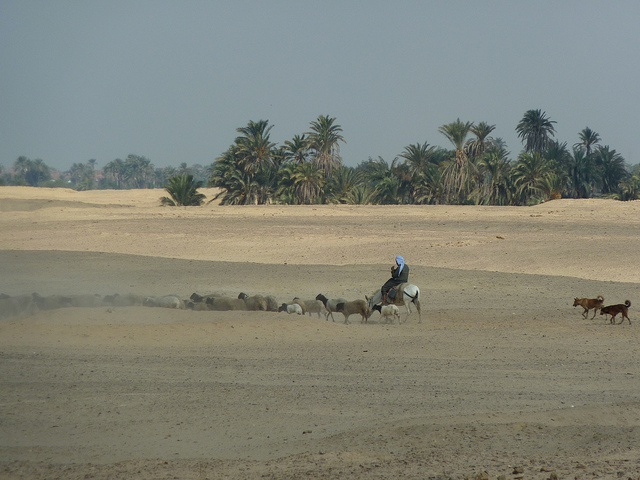Describe the objects in this image and their specific colors. I can see horse in gray, black, and darkgray tones, people in gray, black, and darkgray tones, sheep in gray and black tones, dog in gray and black tones, and dog in gray, black, and maroon tones in this image. 